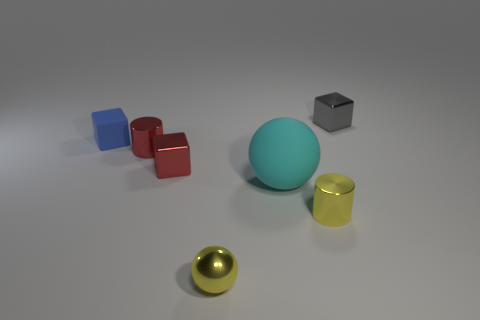What is the shape of the other object that is made of the same material as the blue object?
Provide a short and direct response. Sphere. Does the big sphere have the same material as the red block?
Your answer should be compact. No. Is the number of tiny red shiny things left of the yellow metallic cylinder less than the number of shiny objects in front of the tiny matte block?
Provide a short and direct response. Yes. The shiny thing that is the same color as the shiny ball is what size?
Offer a terse response. Small. There is a rubber thing on the left side of the yellow ball that is in front of the cyan thing; how many yellow things are to the left of it?
Your answer should be compact. 0. Do the tiny matte thing and the big ball have the same color?
Your response must be concise. No. Are there any small metallic cylinders that have the same color as the metallic ball?
Give a very brief answer. Yes. There is a shiny cube that is the same size as the gray thing; what is its color?
Ensure brevity in your answer.  Red. Are there any big cyan objects that have the same shape as the gray shiny thing?
Provide a succinct answer. No. What is the shape of the object that is the same color as the tiny ball?
Your response must be concise. Cylinder. 